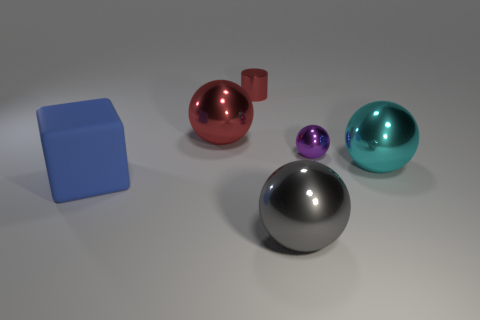There is a sphere that is the same color as the cylinder; what is it made of?
Make the answer very short. Metal. How many objects are small things that are left of the small purple metallic thing or large blue rubber things?
Ensure brevity in your answer.  2. Does the ball that is on the left side of the gray object have the same size as the big blue thing?
Your response must be concise. Yes. Are there fewer cyan metallic things in front of the tiny ball than large cyan metallic things?
Provide a short and direct response. No. There is a gray object that is the same size as the rubber cube; what is its material?
Give a very brief answer. Metal. How many big things are either cyan metallic balls or purple things?
Your answer should be compact. 1. How many things are either large red spheres behind the small metallic sphere or large metal spheres to the left of the gray shiny object?
Your answer should be very brief. 1. Are there fewer shiny objects than red balls?
Give a very brief answer. No. There is a blue object that is the same size as the red sphere; what is its shape?
Make the answer very short. Cube. How many other things are there of the same color as the small sphere?
Offer a very short reply. 0. 